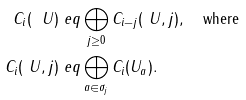<formula> <loc_0><loc_0><loc_500><loc_500>C _ { i } ( \ U ) & \ e q \bigoplus _ { j \geq 0 } C _ { i - j } ( \ U , j ) , \quad \text {where} \\ C _ { i } ( \ U , j ) & \ e q \bigoplus _ { a \in \sigma _ { j } } C _ { i } ( U _ { a } ) .</formula> 